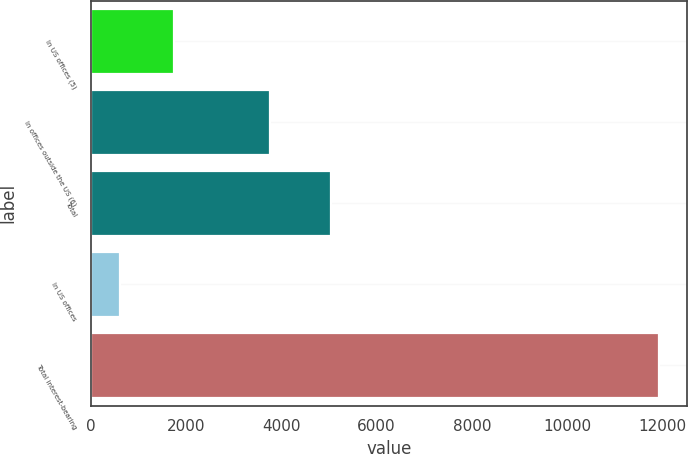<chart> <loc_0><loc_0><loc_500><loc_500><bar_chart><fcel>In US offices (5)<fcel>In offices outside the US (6)<fcel>Total<fcel>In US offices<fcel>Total interest-bearing<nl><fcel>1744.7<fcel>3761<fcel>5052<fcel>614<fcel>11921<nl></chart> 